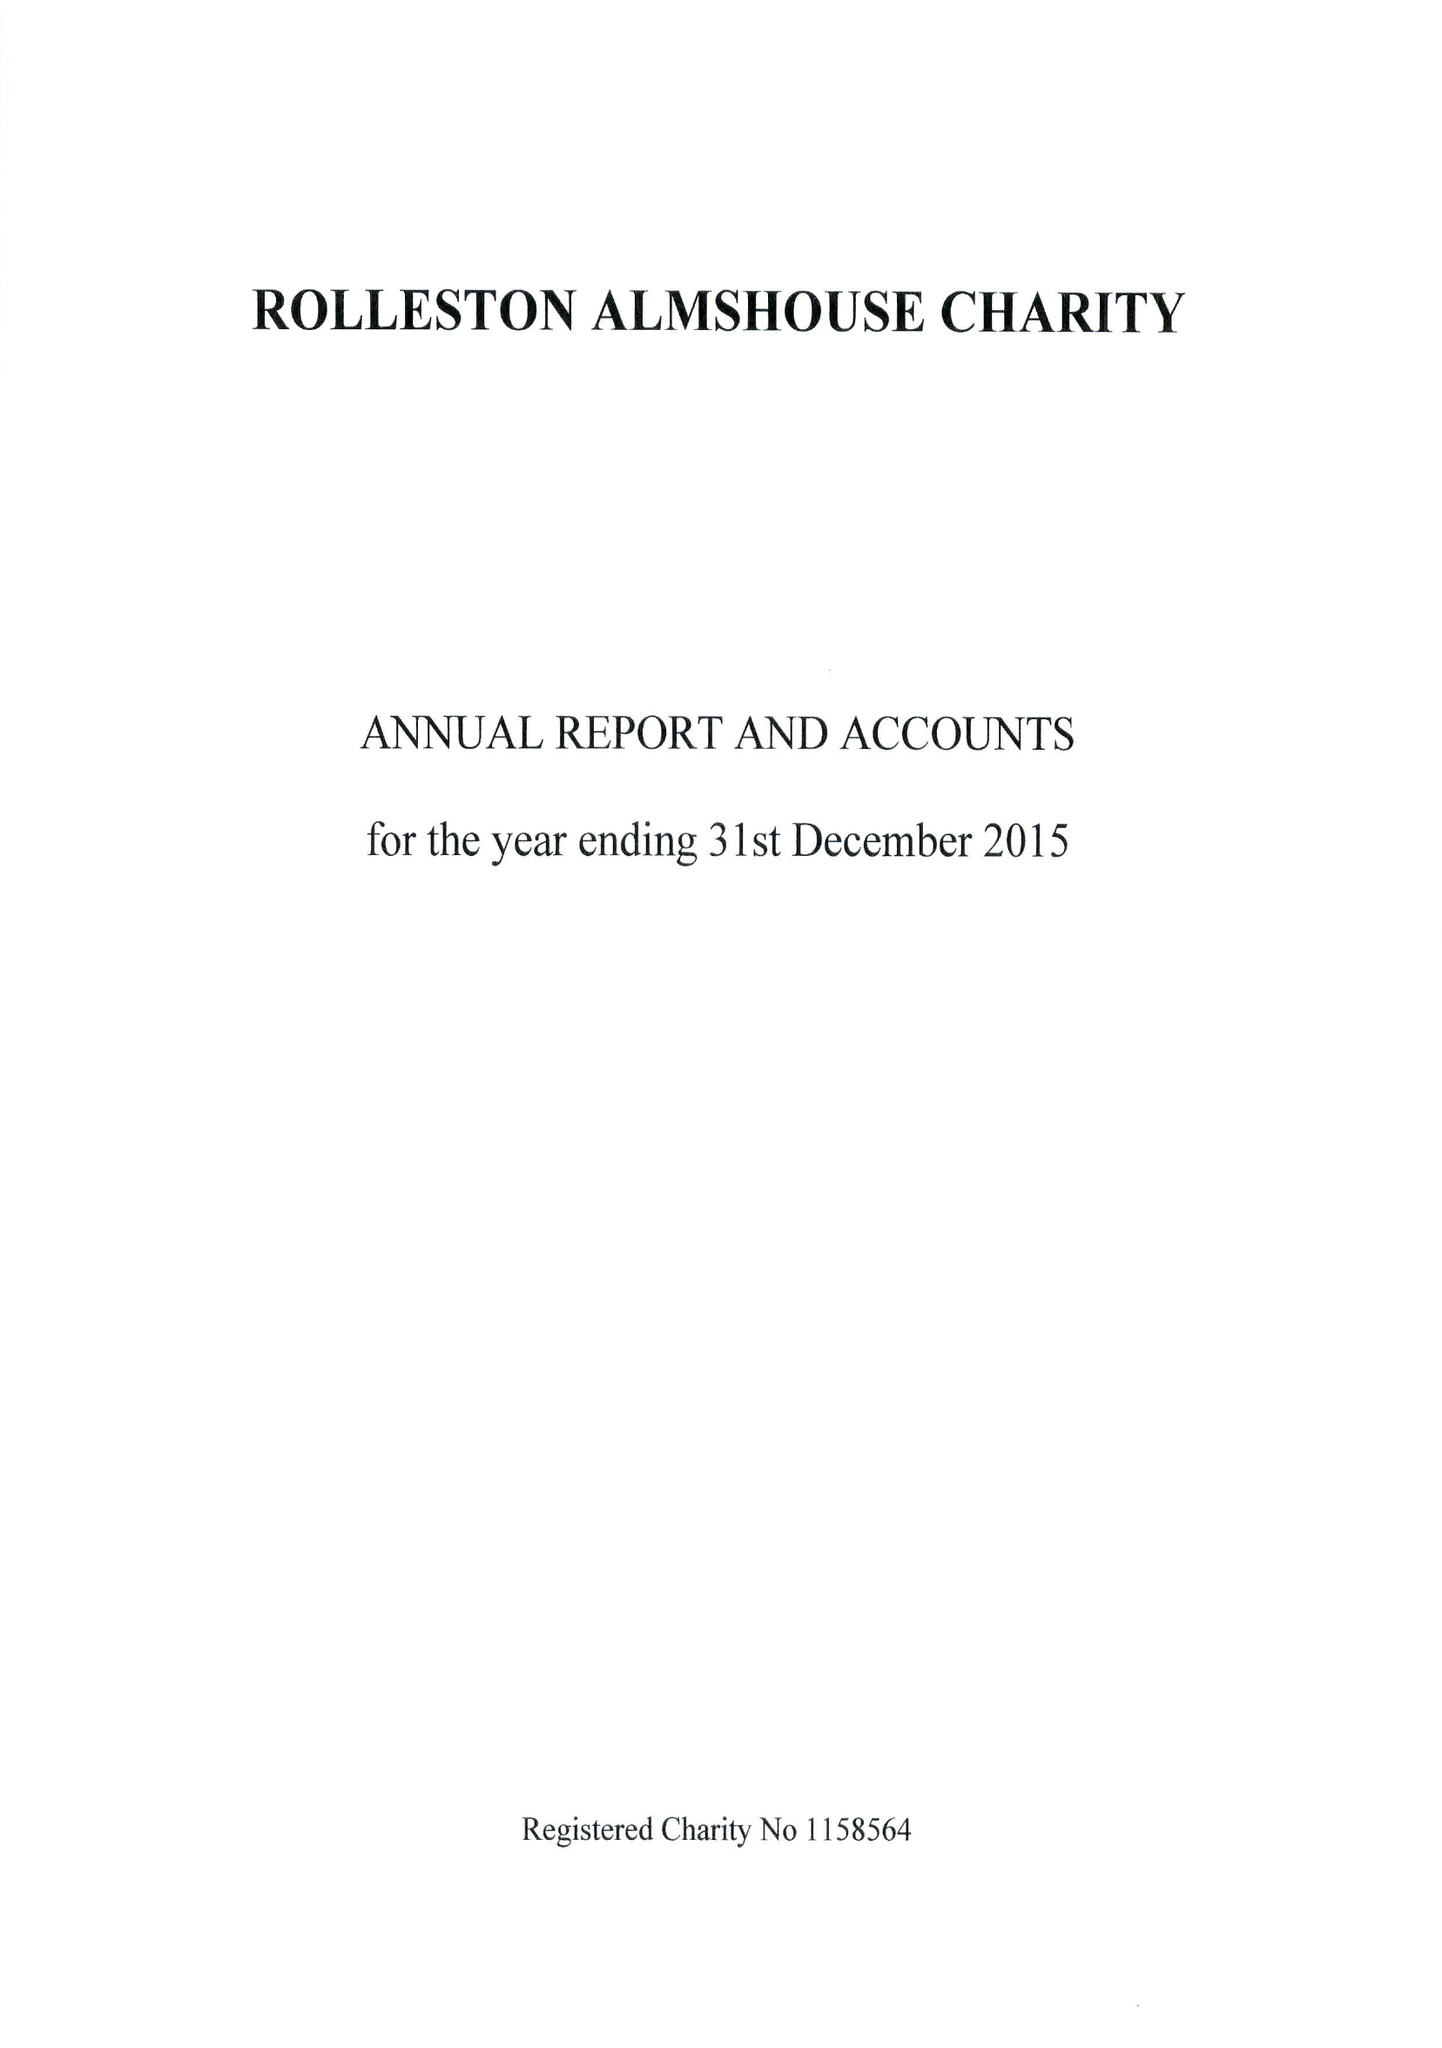What is the value for the charity_number?
Answer the question using a single word or phrase. 1158564 